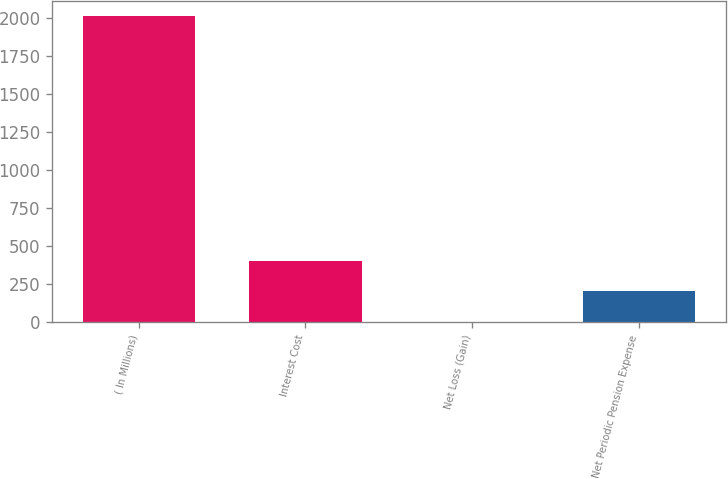<chart> <loc_0><loc_0><loc_500><loc_500><bar_chart><fcel>( In Millions)<fcel>Interest Cost<fcel>Net Loss (Gain)<fcel>Net Periodic Pension Expense<nl><fcel>2014<fcel>404.08<fcel>1.6<fcel>202.84<nl></chart> 